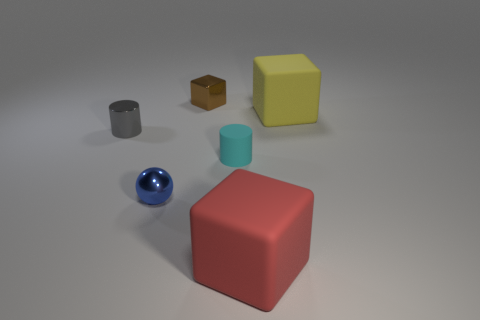Subtract all matte cubes. How many cubes are left? 1 Add 1 large brown cylinders. How many objects exist? 7 Subtract all balls. How many objects are left? 5 Subtract all small green cubes. Subtract all large red matte things. How many objects are left? 5 Add 5 small gray objects. How many small gray objects are left? 6 Add 4 red blocks. How many red blocks exist? 5 Subtract 0 blue blocks. How many objects are left? 6 